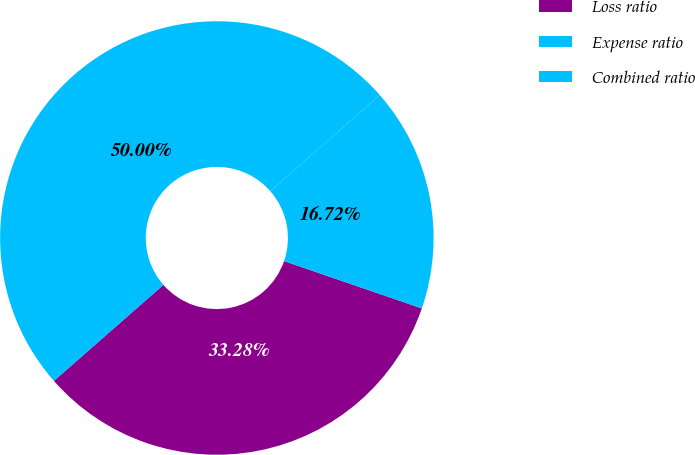Convert chart. <chart><loc_0><loc_0><loc_500><loc_500><pie_chart><fcel>Loss ratio<fcel>Expense ratio<fcel>Combined ratio<nl><fcel>33.28%<fcel>16.72%<fcel>50.0%<nl></chart> 